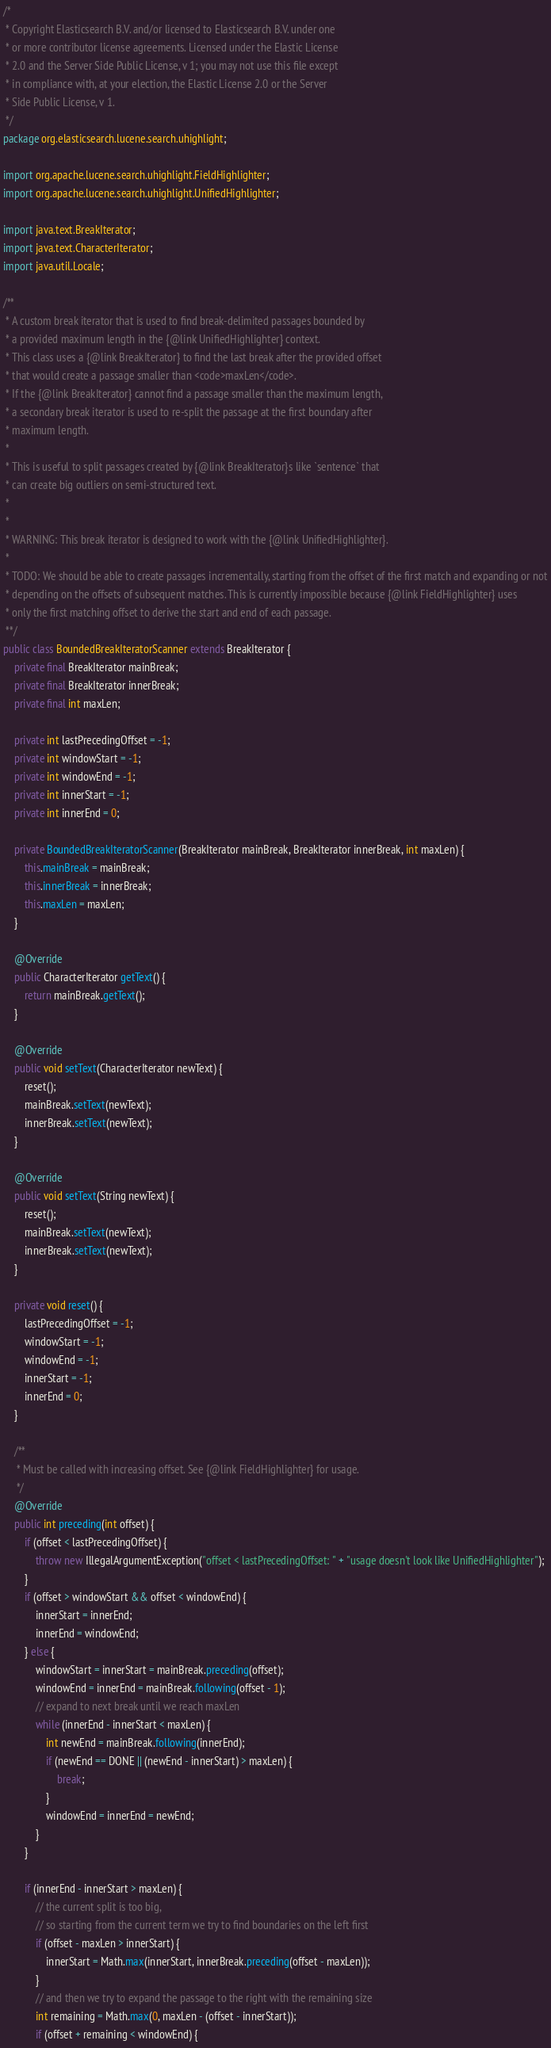<code> <loc_0><loc_0><loc_500><loc_500><_Java_>/*
 * Copyright Elasticsearch B.V. and/or licensed to Elasticsearch B.V. under one
 * or more contributor license agreements. Licensed under the Elastic License
 * 2.0 and the Server Side Public License, v 1; you may not use this file except
 * in compliance with, at your election, the Elastic License 2.0 or the Server
 * Side Public License, v 1.
 */
package org.elasticsearch.lucene.search.uhighlight;

import org.apache.lucene.search.uhighlight.FieldHighlighter;
import org.apache.lucene.search.uhighlight.UnifiedHighlighter;

import java.text.BreakIterator;
import java.text.CharacterIterator;
import java.util.Locale;

/**
 * A custom break iterator that is used to find break-delimited passages bounded by
 * a provided maximum length in the {@link UnifiedHighlighter} context.
 * This class uses a {@link BreakIterator} to find the last break after the provided offset
 * that would create a passage smaller than <code>maxLen</code>.
 * If the {@link BreakIterator} cannot find a passage smaller than the maximum length,
 * a secondary break iterator is used to re-split the passage at the first boundary after
 * maximum length.
 *
 * This is useful to split passages created by {@link BreakIterator}s like `sentence` that
 * can create big outliers on semi-structured text.
 *
 *
 * WARNING: This break iterator is designed to work with the {@link UnifiedHighlighter}.
 *
 * TODO: We should be able to create passages incrementally, starting from the offset of the first match and expanding or not
 * depending on the offsets of subsequent matches. This is currently impossible because {@link FieldHighlighter} uses
 * only the first matching offset to derive the start and end of each passage.
 **/
public class BoundedBreakIteratorScanner extends BreakIterator {
    private final BreakIterator mainBreak;
    private final BreakIterator innerBreak;
    private final int maxLen;

    private int lastPrecedingOffset = -1;
    private int windowStart = -1;
    private int windowEnd = -1;
    private int innerStart = -1;
    private int innerEnd = 0;

    private BoundedBreakIteratorScanner(BreakIterator mainBreak, BreakIterator innerBreak, int maxLen) {
        this.mainBreak = mainBreak;
        this.innerBreak = innerBreak;
        this.maxLen = maxLen;
    }

    @Override
    public CharacterIterator getText() {
        return mainBreak.getText();
    }

    @Override
    public void setText(CharacterIterator newText) {
        reset();
        mainBreak.setText(newText);
        innerBreak.setText(newText);
    }

    @Override
    public void setText(String newText) {
        reset();
        mainBreak.setText(newText);
        innerBreak.setText(newText);
    }

    private void reset() {
        lastPrecedingOffset = -1;
        windowStart = -1;
        windowEnd = -1;
        innerStart = -1;
        innerEnd = 0;
    }

    /**
     * Must be called with increasing offset. See {@link FieldHighlighter} for usage.
     */
    @Override
    public int preceding(int offset) {
        if (offset < lastPrecedingOffset) {
            throw new IllegalArgumentException("offset < lastPrecedingOffset: " + "usage doesn't look like UnifiedHighlighter");
        }
        if (offset > windowStart && offset < windowEnd) {
            innerStart = innerEnd;
            innerEnd = windowEnd;
        } else {
            windowStart = innerStart = mainBreak.preceding(offset);
            windowEnd = innerEnd = mainBreak.following(offset - 1);
            // expand to next break until we reach maxLen
            while (innerEnd - innerStart < maxLen) {
                int newEnd = mainBreak.following(innerEnd);
                if (newEnd == DONE || (newEnd - innerStart) > maxLen) {
                    break;
                }
                windowEnd = innerEnd = newEnd;
            }
        }

        if (innerEnd - innerStart > maxLen) {
            // the current split is too big,
            // so starting from the current term we try to find boundaries on the left first
            if (offset - maxLen > innerStart) {
                innerStart = Math.max(innerStart, innerBreak.preceding(offset - maxLen));
            }
            // and then we try to expand the passage to the right with the remaining size
            int remaining = Math.max(0, maxLen - (offset - innerStart));
            if (offset + remaining < windowEnd) {</code> 